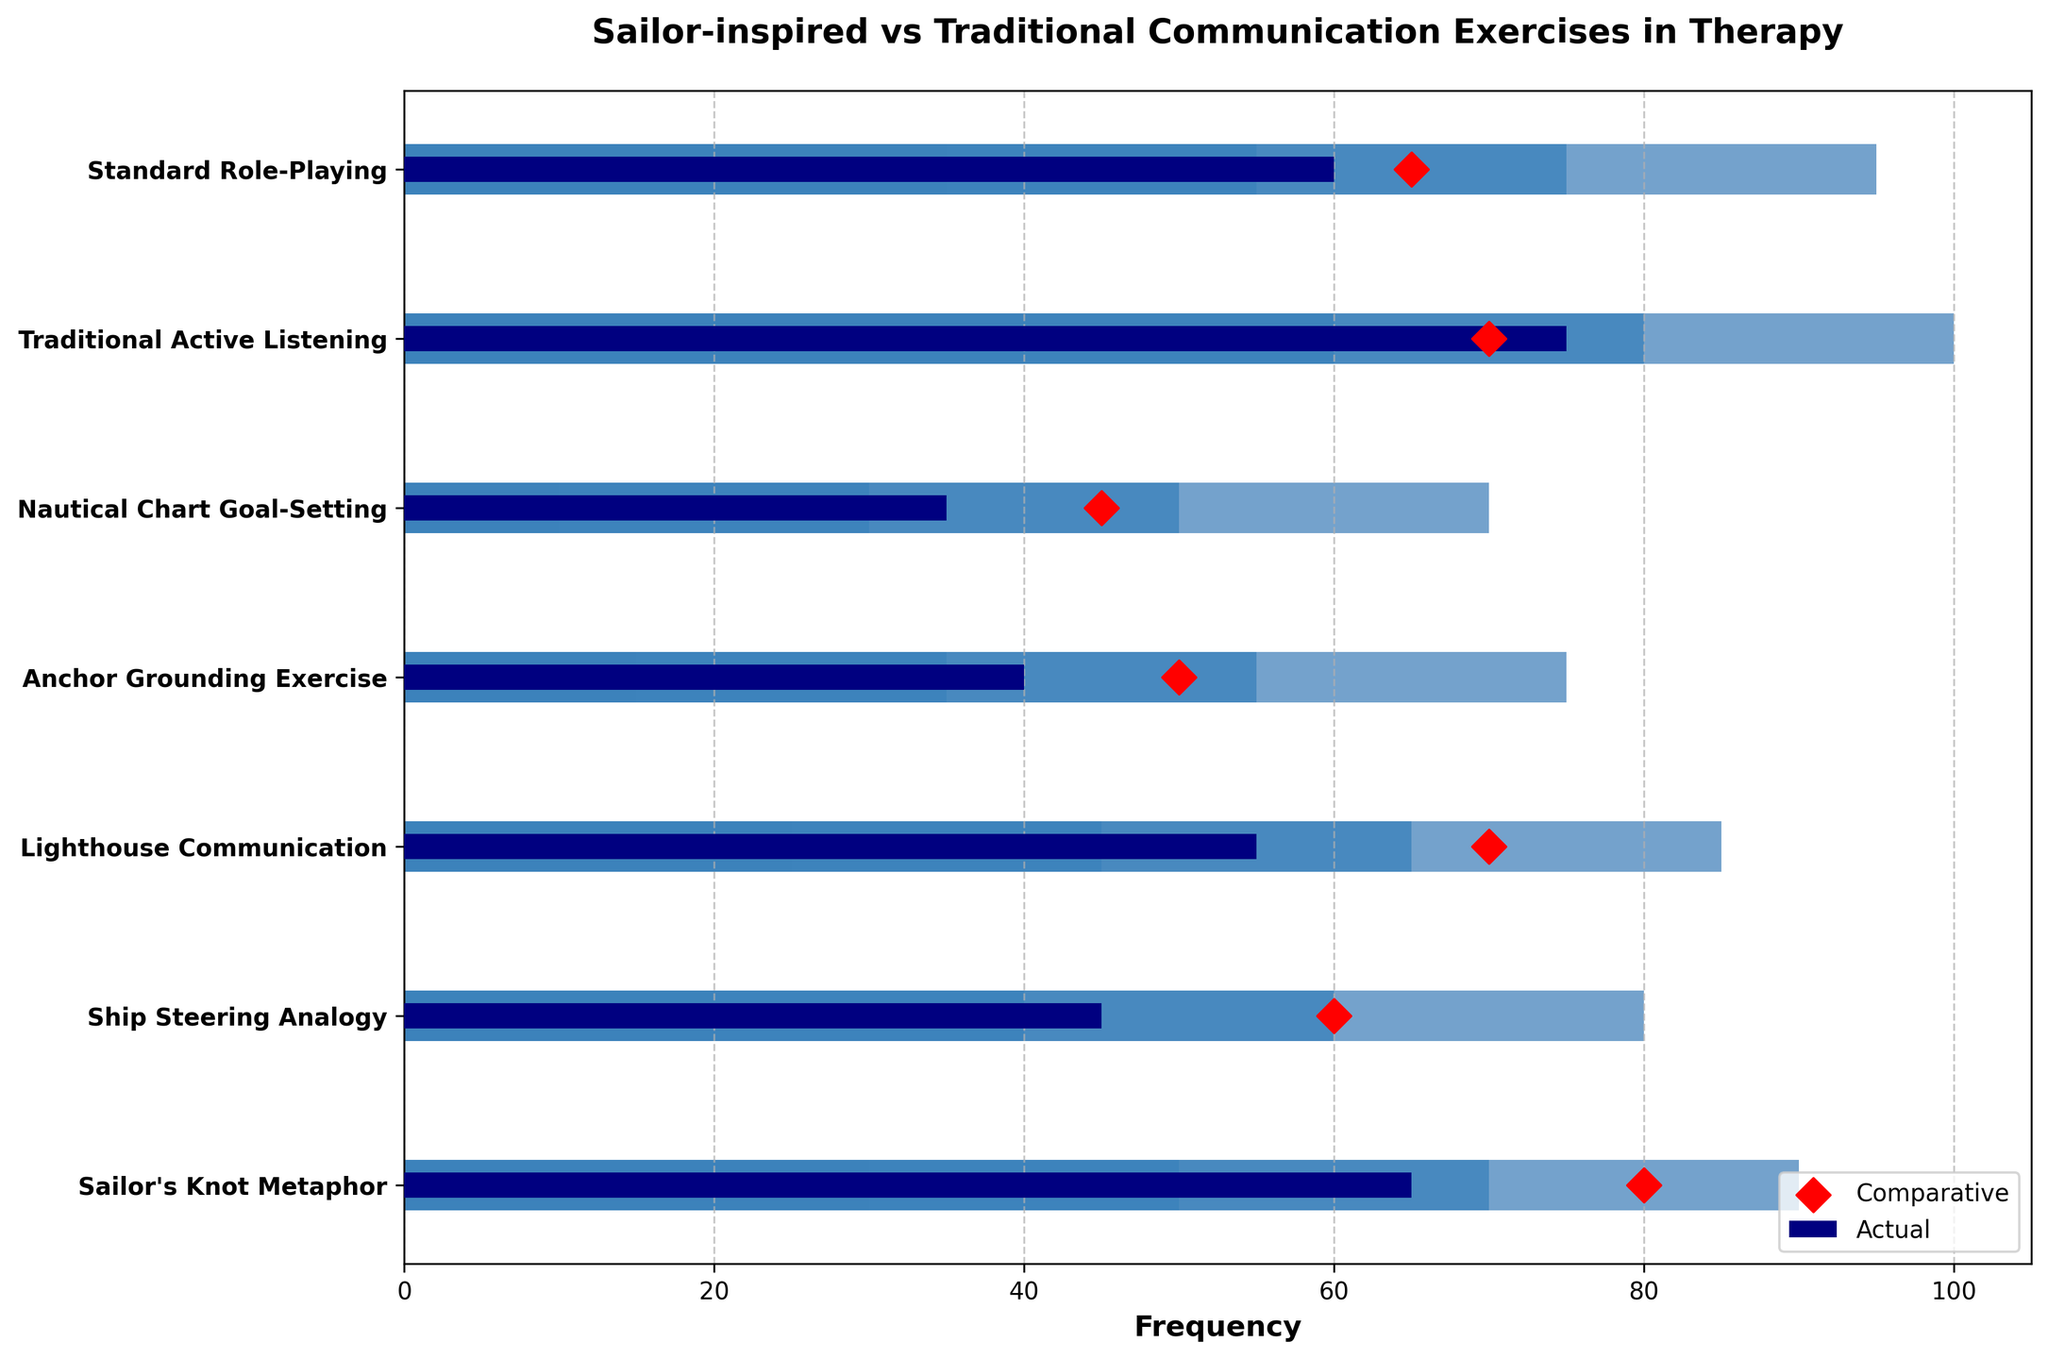What is the title of the figure? The title is typically displayed at the top of the figure. Here, it reads: "Sailor-inspired vs Traditional Communication Exercises in Therapy".
Answer: Sailor-inspired vs Traditional Communication Exercises in Therapy Which exercise has the highest actual frequency? By looking at the blue bars in the figure, the "Traditional Active Listening" exercise has the longest blue bar, indicating the highest actual frequency.
Answer: Traditional Active Listening How many types of communication exercises are represented in the chart? By counting the different labels along the y-axis, we see there are seven types of communication exercises represented.
Answer: Seven What is the comparative frequency of the "Ship Steering Analogy" exercise? The red diamond marker for the "Ship Steering Analogy" exercise shows a comparative frequency of 60.
Answer: 60 Compare the actual and comparative frequencies of the "Nautical Chart Goal-Setting" exercise. Which is higher? The actual frequency bar is at 35, and the comparative diamond marker is at 45. The comparative frequency is higher.
Answer: Comparative is higher What is the range of the highest category in the "Lighthouse Communication" exercise? The lightest color bar (outermost) in the "Lighthouse Communication" exercise represents a range of values from 0 to 85.
Answer: 0 to 85 Which exercise has the smallest difference between actual and comparative frequencies? For each exercise, compare the actual and comparative values and calculate the difference: 
- "Sailor's Knot Metaphor": 80 - 65 = 15 
- "Ship Steering Analogy": 60 - 45 = 15 
- "Lighthouse Communication": 70 - 55 = 15 
- "Anchor Grounding Exercise": 50 - 40 = 10 
- "Nautical Chart Goal-Setting": 45 - 35 = 10 
- "Traditional Active Listening": 70 - 75 = 5 
- "Standard Role-Playing": 65 - 60 = 5 
The "Traditional Active Listening" and "Standard Role-Playing" exercises both have the smallest difference, which is 5.
Answer: Traditional Active Listening and Standard Role-Playing What is the combined actual frequency of all sailor-inspired exercises? Sum the actual frequencies of the sailor-inspired exercises:
65 (Sailor's Knot Metaphor) + 45 (Ship Steering Analogy) + 55 (Lighthouse Communication) + 40 (Anchor Grounding Exercise) + 35 (Nautical Chart Goal-Setting) = 240
Answer: 240 How does "Traditional Active Listening" compare to the ranges of all sailor-inspired exercises? "Traditional Active Listening" has an actual frequency of 75. This value is higher than the upper bound of the highest range of any sailor-inspired exercise, which is 70. Hence, it exceeds all sailor-inspired ranges.
Answer: Exceeds all Which Sailor-inspired exercise has an actual frequency closest to its comparative value, and what is that value? The "Sailor's Knot Metaphor" has an actual value of 65 and a comparative value of 80. The difference is 15. 
The "Ship Steering Analogy" has 45 actual and 60 comparative, a difference of 15. 
The "Lighthouse Communication" has 55 actual and 70 comparative, a difference of 15. 
The "Anchor Grounding Exercise" has 40 actual and 50 comparative, a difference of 10. 
The "Nautical Chart Goal-Setting" has 35 actual and 45 comparative, a difference of 10. 
The "Anchor Grounding Exercise" along with "Nautical Chart Goal-Setting" has an actual frequency closest to its comparative value, which is 10.
Answer: Anchor Grounding Exercise and Nautical Chart Goal-Setting 